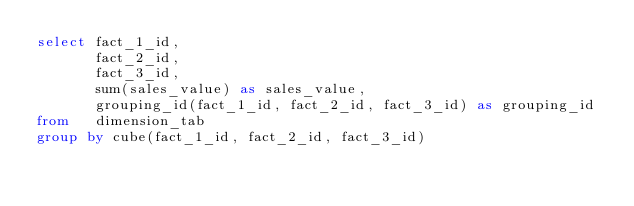Convert code to text. <code><loc_0><loc_0><loc_500><loc_500><_SQL_>select fact_1_id,
       fact_2_id,
       fact_3_id,
       sum(sales_value) as sales_value,
       grouping_id(fact_1_id, fact_2_id, fact_3_id) as grouping_id
from   dimension_tab
group by cube(fact_1_id, fact_2_id, fact_3_id)</code> 